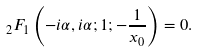<formula> <loc_0><loc_0><loc_500><loc_500>_ { 2 } F _ { 1 } \left ( - i \alpha , i \alpha ; 1 ; - \frac { 1 } { x _ { 0 } } \right ) = 0 .</formula> 